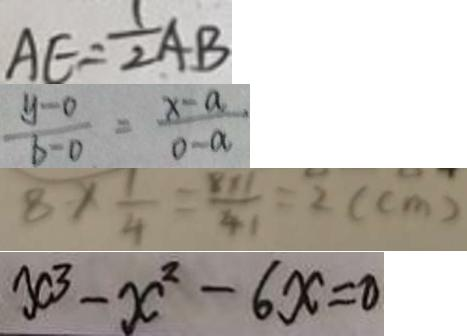Convert formula to latex. <formula><loc_0><loc_0><loc_500><loc_500>A E = \frac { 1 } { 2 } A B 
 \frac { y - 0 } { b - 0 } = \frac { x - a } { 0 - a } 
 8 \times \frac { 1 } { 4 } = \frac { 8 \times 1 } { 4 } = 2 ( c m ) 
 x ^ { 3 } - x ^ { 2 } - 6 x = 0</formula> 